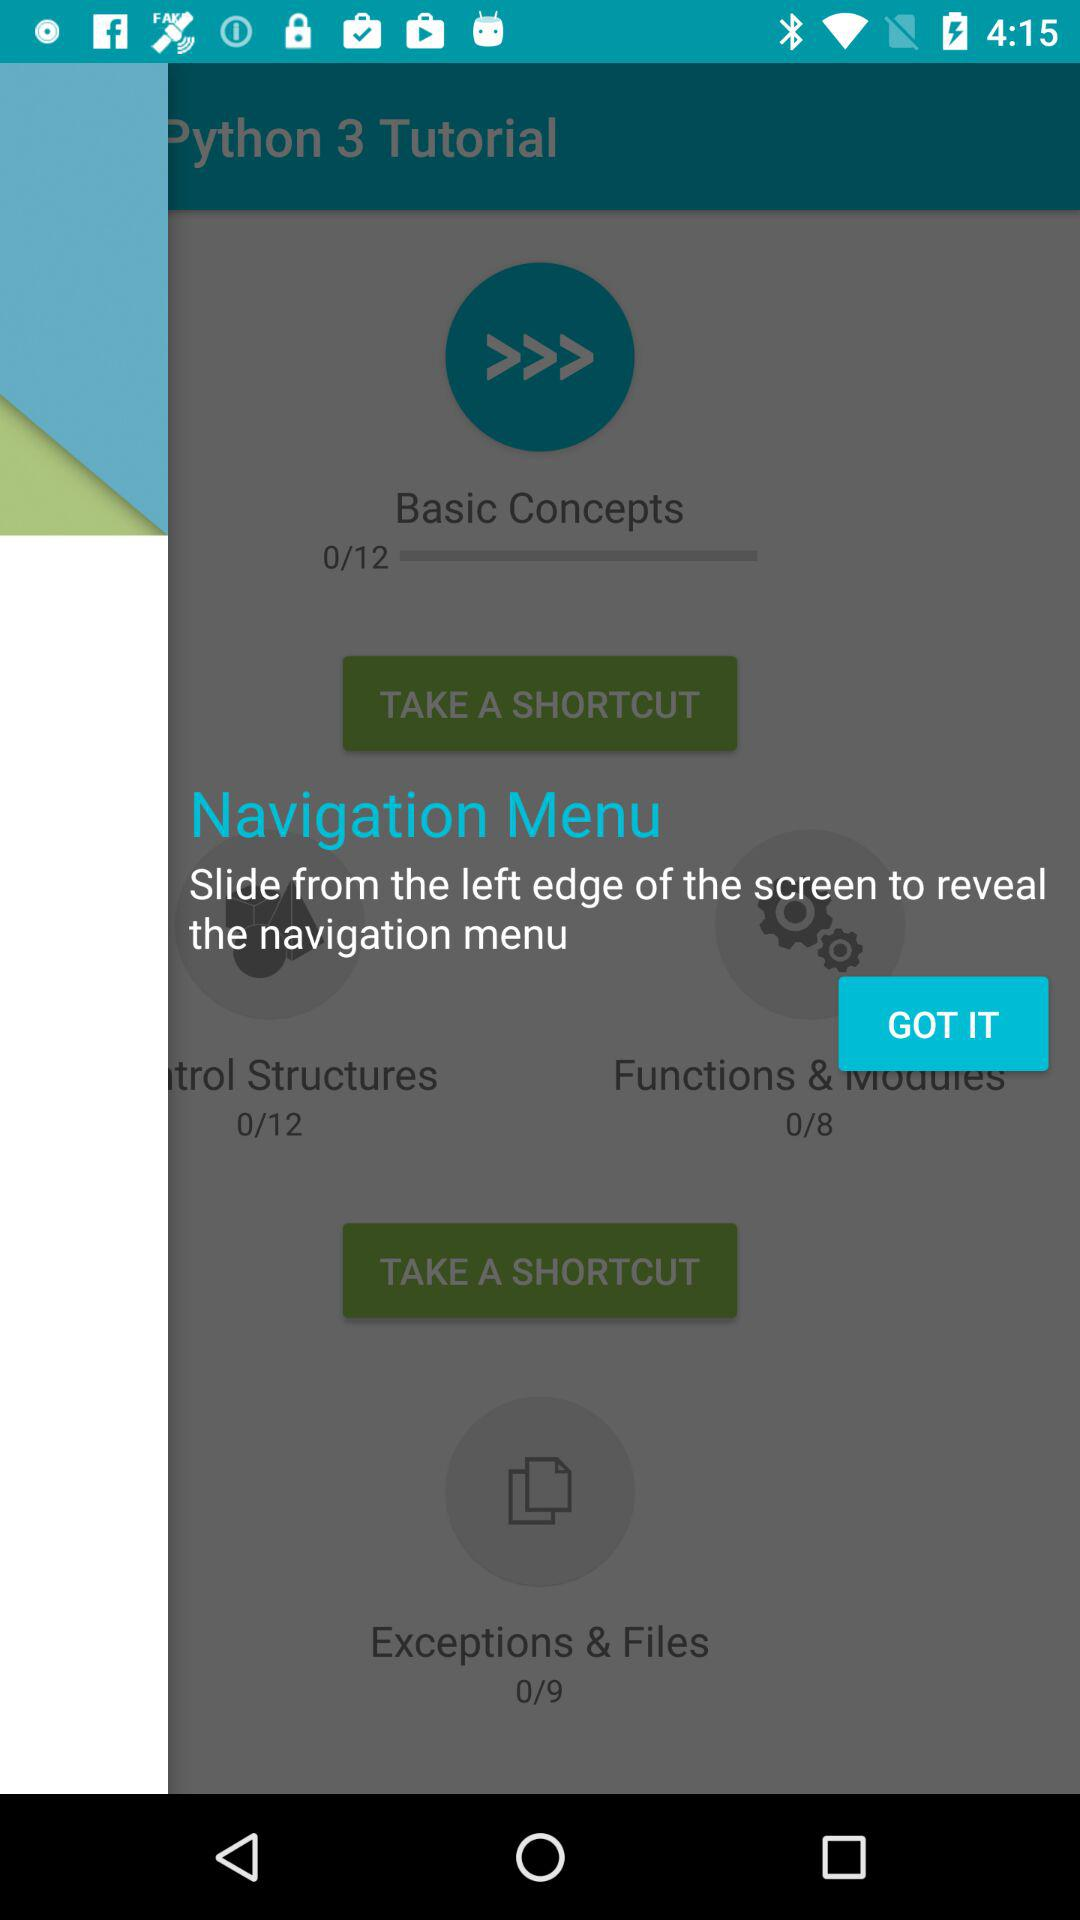How many chapter in total are there in "Basic Concepts"? There are 12 chapters in "Basic Concepts". 